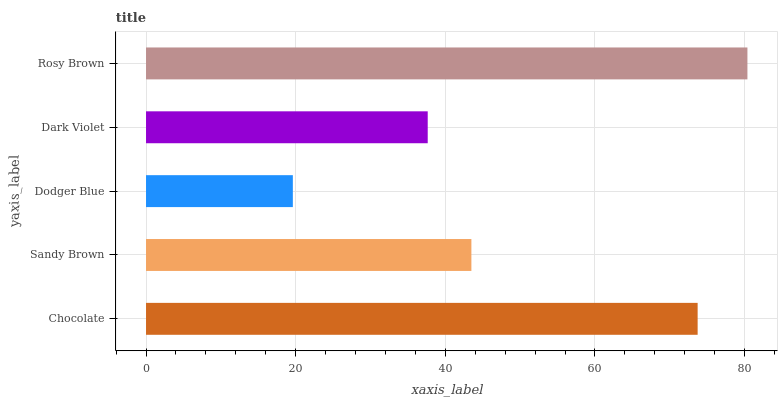Is Dodger Blue the minimum?
Answer yes or no. Yes. Is Rosy Brown the maximum?
Answer yes or no. Yes. Is Sandy Brown the minimum?
Answer yes or no. No. Is Sandy Brown the maximum?
Answer yes or no. No. Is Chocolate greater than Sandy Brown?
Answer yes or no. Yes. Is Sandy Brown less than Chocolate?
Answer yes or no. Yes. Is Sandy Brown greater than Chocolate?
Answer yes or no. No. Is Chocolate less than Sandy Brown?
Answer yes or no. No. Is Sandy Brown the high median?
Answer yes or no. Yes. Is Sandy Brown the low median?
Answer yes or no. Yes. Is Chocolate the high median?
Answer yes or no. No. Is Dark Violet the low median?
Answer yes or no. No. 